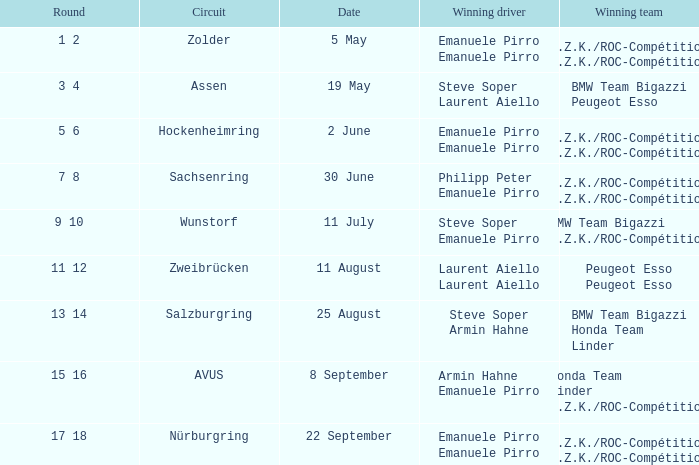Which team emerged victorious on july 11th? BMW Team Bigazzi A.Z.K./ROC-Compétition. 